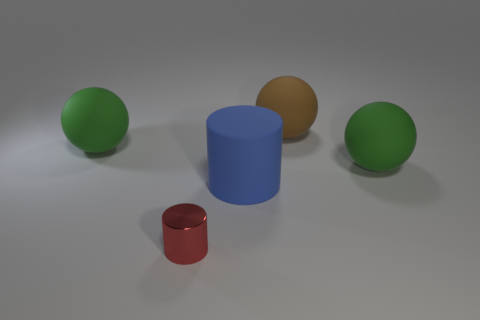What is the texture of the surface the objects are on? The surface appears smooth and matte, likely simulating an idealized studio environment. It reflects some light but not enough to produce a mirrored effect.  How do the objects relate in terms of proportions? The objects are displayed with varying proportions. The two green spheres seem identical and smaller in volume compared to the blue cylinder. The shiny red cylinder is the smallest in terms of height and volume, while the brown sphere sits in between in size. 